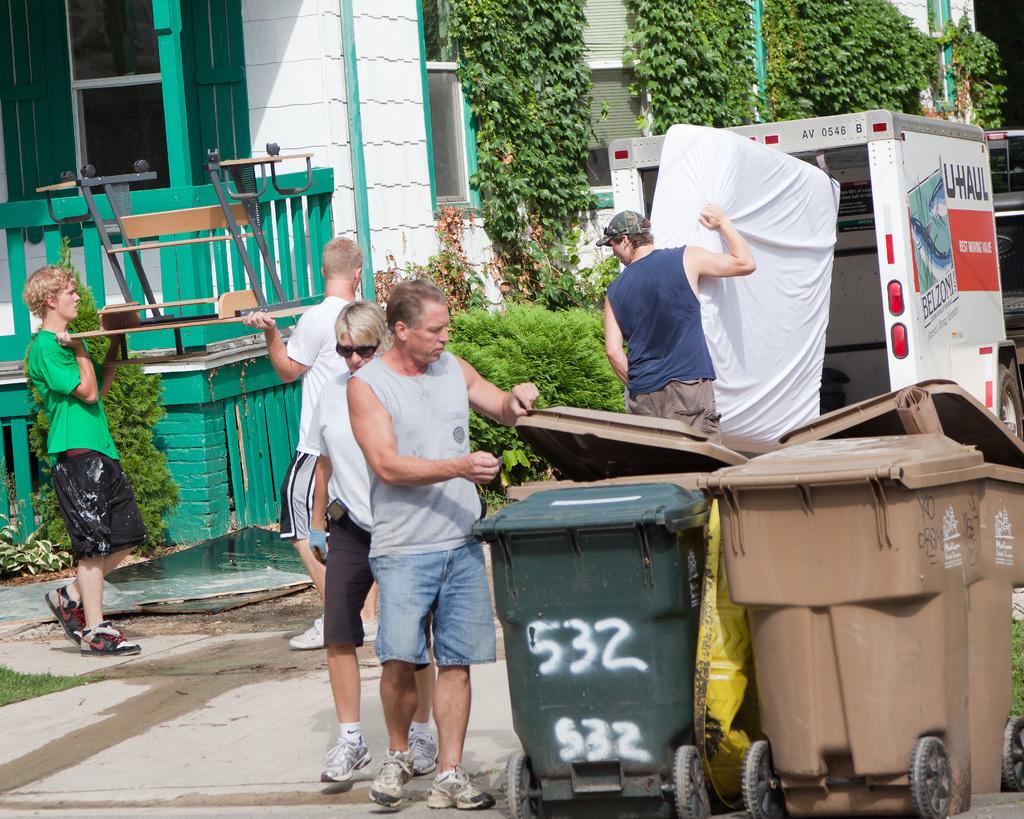What number is spray painted on the trash can?
Provide a short and direct response. 532. 